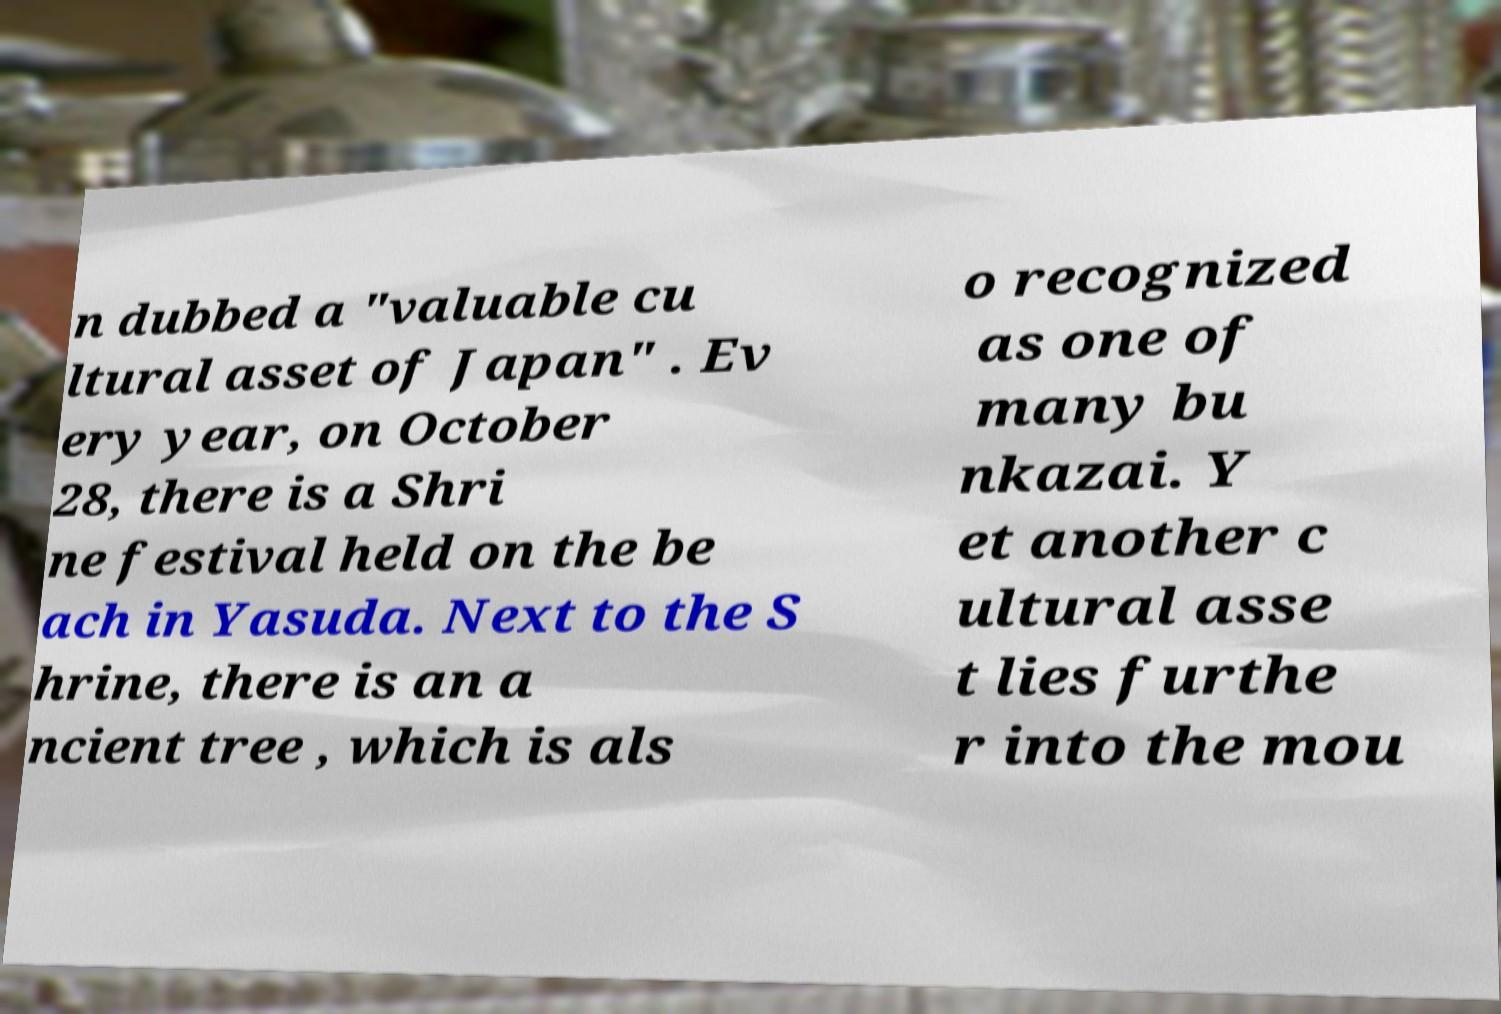Can you read and provide the text displayed in the image?This photo seems to have some interesting text. Can you extract and type it out for me? n dubbed a "valuable cu ltural asset of Japan" . Ev ery year, on October 28, there is a Shri ne festival held on the be ach in Yasuda. Next to the S hrine, there is an a ncient tree , which is als o recognized as one of many bu nkazai. Y et another c ultural asse t lies furthe r into the mou 